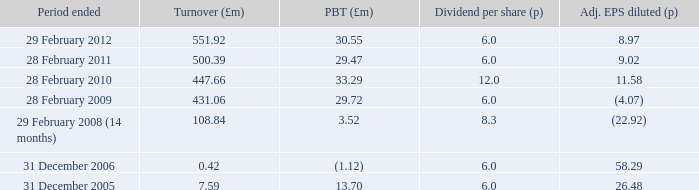What was the turnover when the profit before tax was 29.47? 500.39. 